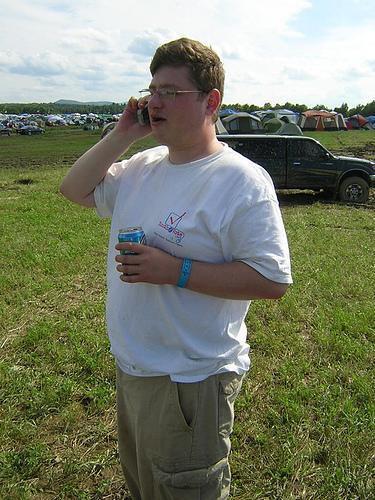Evaluate: Does the caption "The truck is touching the person." match the image?
Answer yes or no. No. 